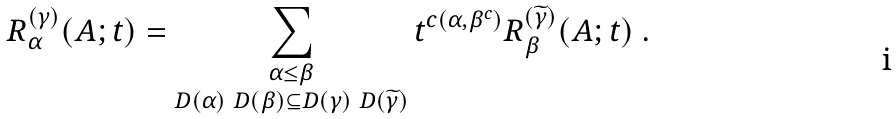Convert formula to latex. <formula><loc_0><loc_0><loc_500><loc_500>R _ { \alpha } ^ { ( \gamma ) } ( A ; t ) = \sum _ { \substack { \alpha \leq \beta \\ D ( \alpha ) \ D ( \beta ) \subseteq D ( \gamma ) \ D ( \widetilde { \gamma } ) } } t ^ { c ( \alpha , \beta ^ { c } ) } R _ { \beta } ^ { ( \widetilde { \gamma } ) } ( A ; t ) \ .</formula> 